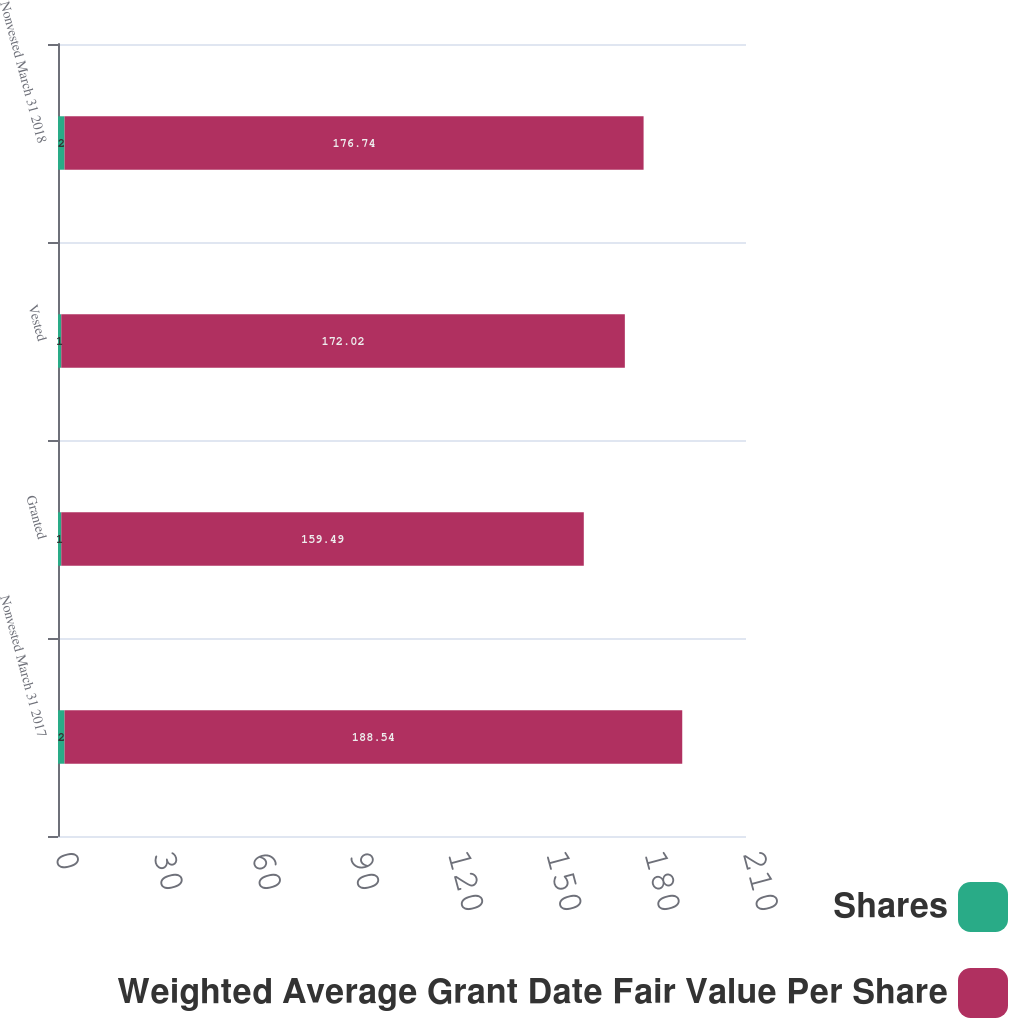Convert chart. <chart><loc_0><loc_0><loc_500><loc_500><stacked_bar_chart><ecel><fcel>Nonvested March 31 2017<fcel>Granted<fcel>Vested<fcel>Nonvested March 31 2018<nl><fcel>Shares<fcel>2<fcel>1<fcel>1<fcel>2<nl><fcel>Weighted Average Grant Date Fair Value Per Share<fcel>188.54<fcel>159.49<fcel>172.02<fcel>176.74<nl></chart> 